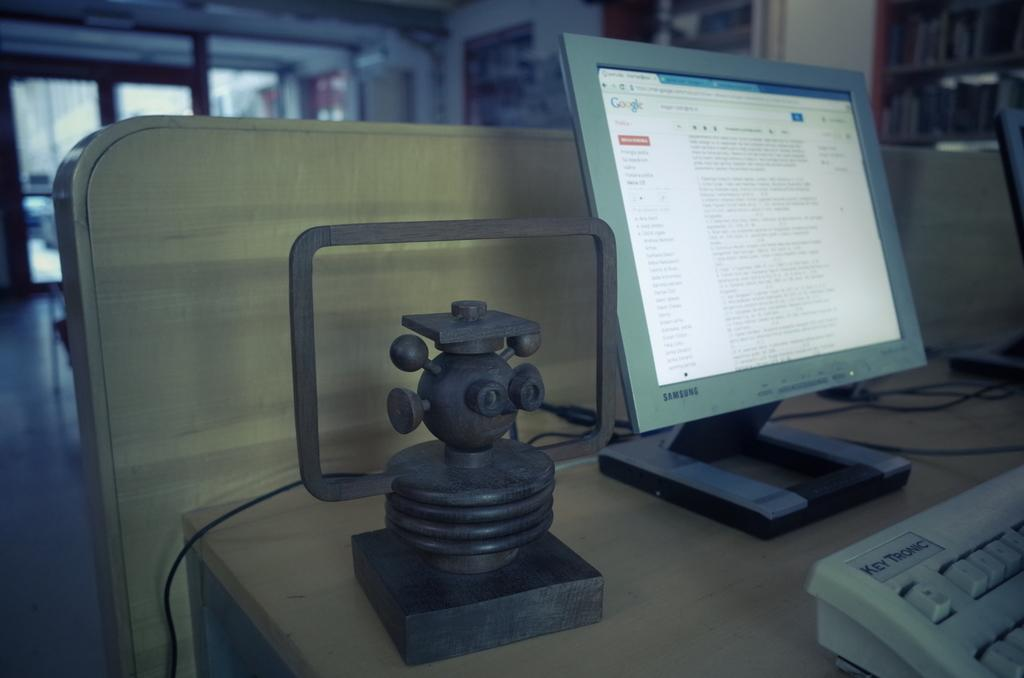<image>
Render a clear and concise summary of the photo. White keyboard in front of a Samsung monitor. 